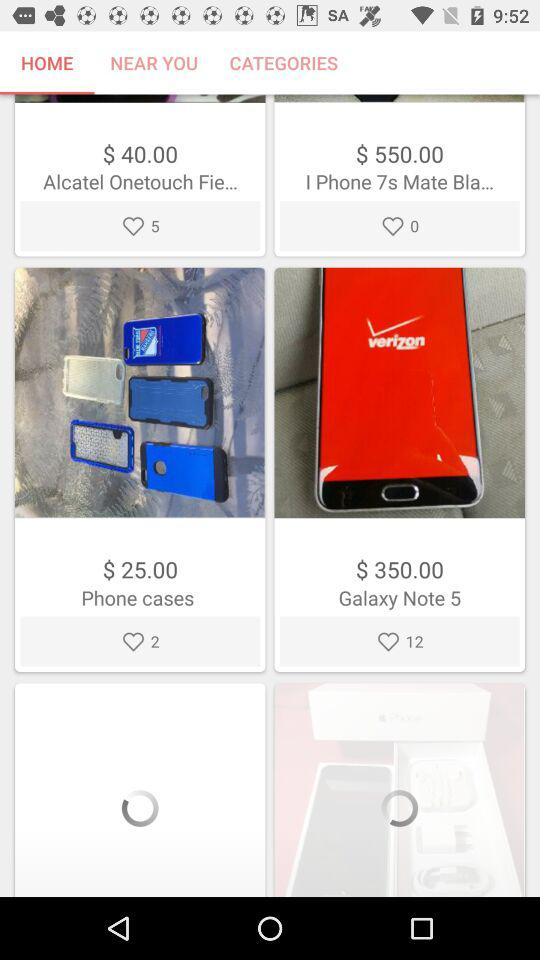How many views does "Galaxy Note 5" have?
When the provided information is insufficient, respond with <no answer>. <no answer> 